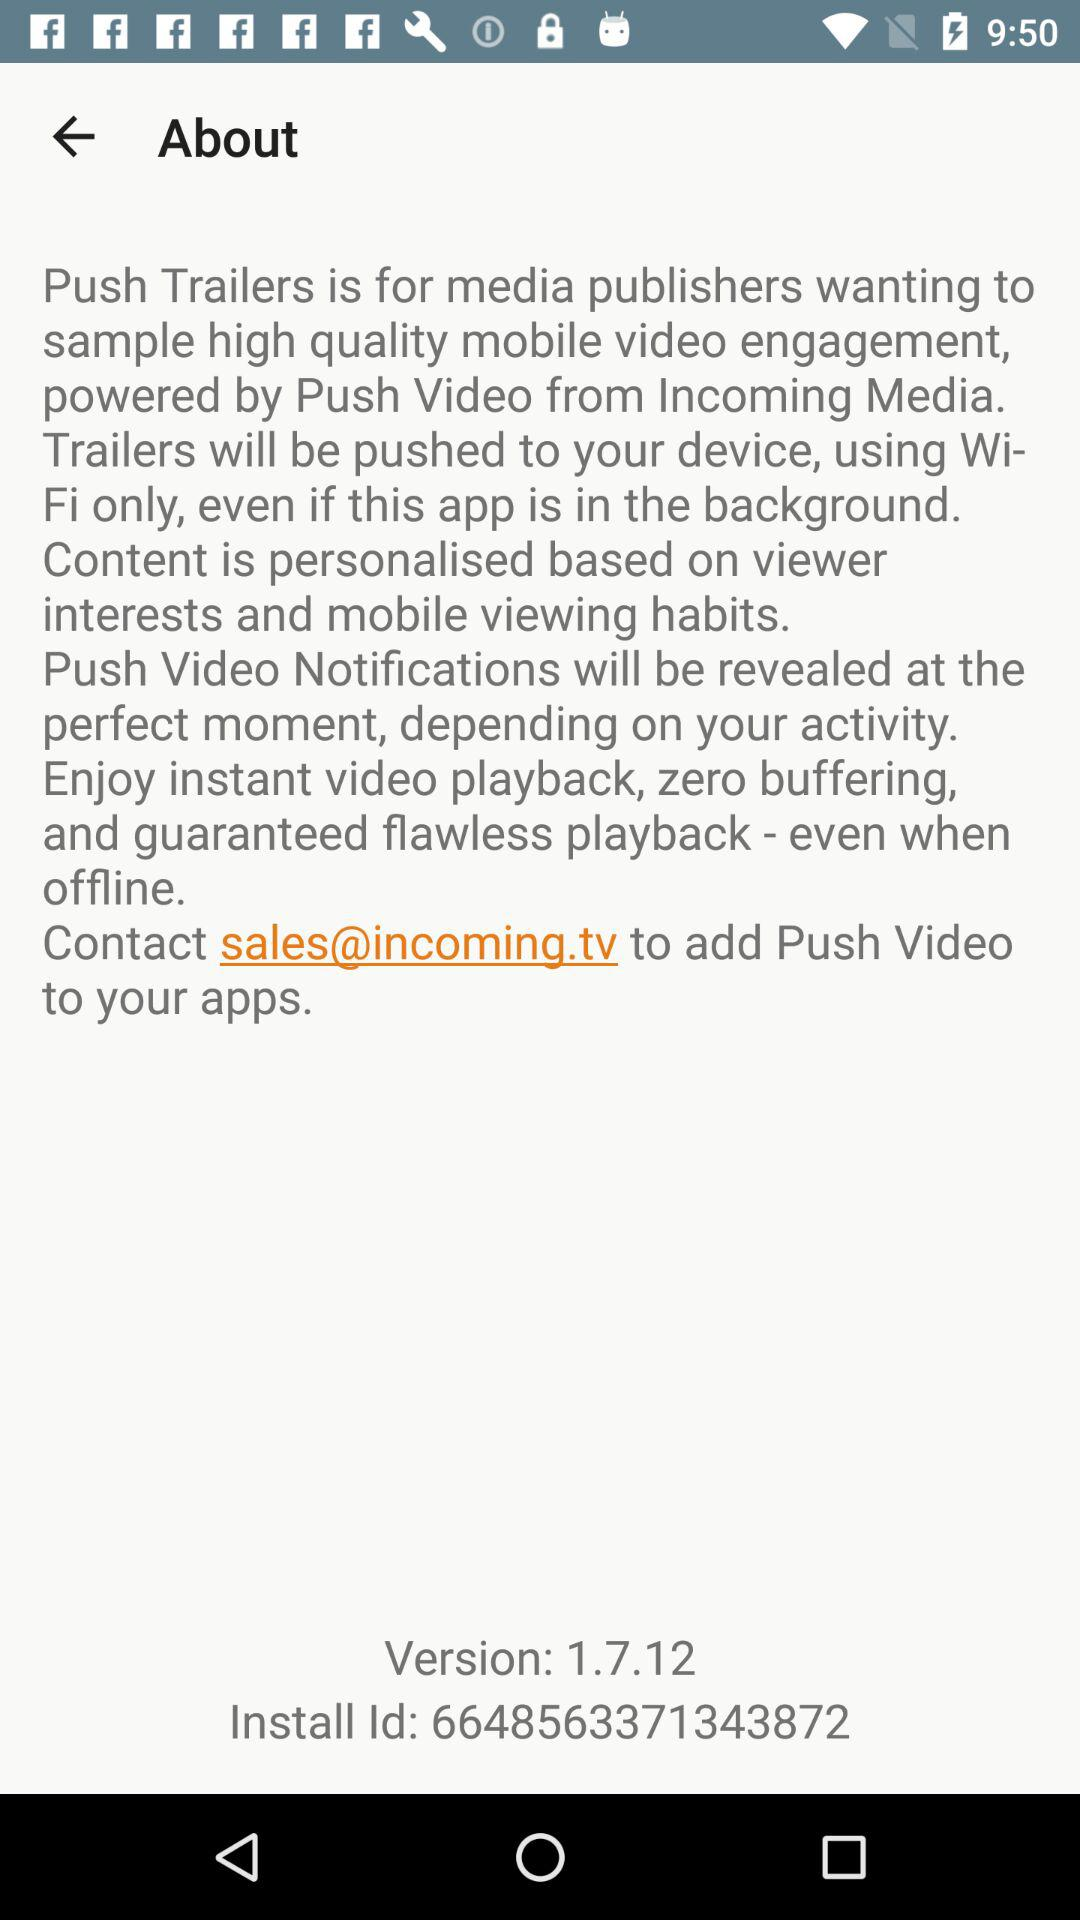What is the install id? The install id is 6648563371343872. 